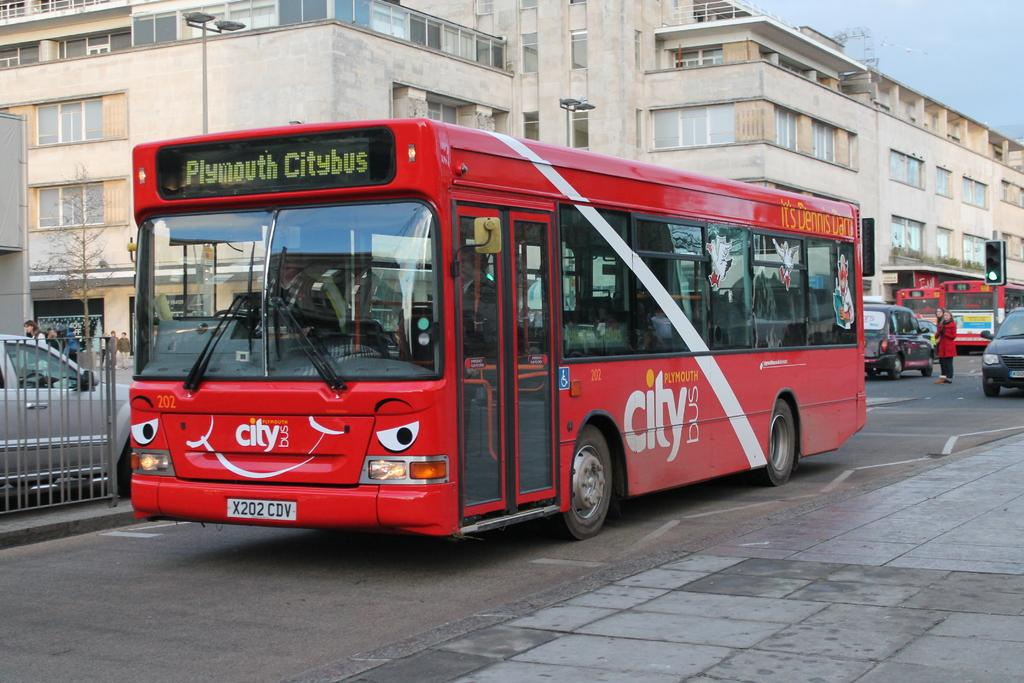Provide a one-sentence caption for the provided image. A medium sized red bus owned by Citybus in Plymouth. 